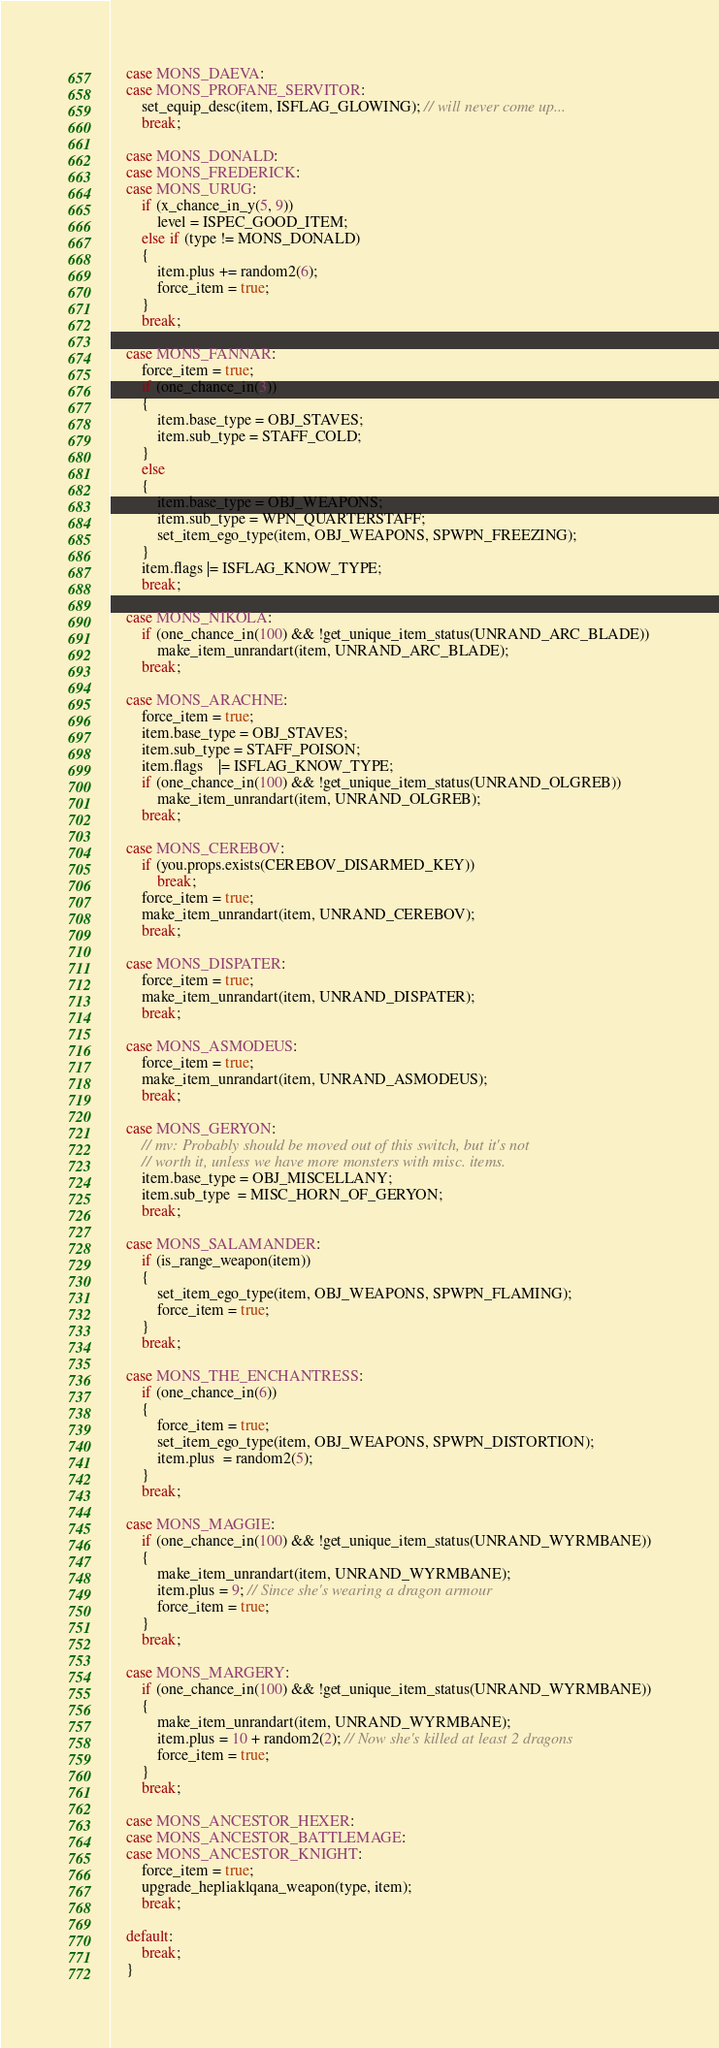<code> <loc_0><loc_0><loc_500><loc_500><_C++_>    case MONS_DAEVA:
    case MONS_PROFANE_SERVITOR:
        set_equip_desc(item, ISFLAG_GLOWING); // will never come up...
        break;

    case MONS_DONALD:
    case MONS_FREDERICK:
    case MONS_URUG:
        if (x_chance_in_y(5, 9))
            level = ISPEC_GOOD_ITEM;
        else if (type != MONS_DONALD)
        {
            item.plus += random2(6);
            force_item = true;
        }
        break;

    case MONS_FANNAR:
        force_item = true;
        if (one_chance_in(3))
        {
            item.base_type = OBJ_STAVES;
            item.sub_type = STAFF_COLD;
        }
        else
        {
            item.base_type = OBJ_WEAPONS;
            item.sub_type = WPN_QUARTERSTAFF;
            set_item_ego_type(item, OBJ_WEAPONS, SPWPN_FREEZING);
        }
        item.flags |= ISFLAG_KNOW_TYPE;
        break;

    case MONS_NIKOLA:
        if (one_chance_in(100) && !get_unique_item_status(UNRAND_ARC_BLADE))
            make_item_unrandart(item, UNRAND_ARC_BLADE);
        break;

    case MONS_ARACHNE:
        force_item = true;
        item.base_type = OBJ_STAVES;
        item.sub_type = STAFF_POISON;
        item.flags    |= ISFLAG_KNOW_TYPE;
        if (one_chance_in(100) && !get_unique_item_status(UNRAND_OLGREB))
            make_item_unrandart(item, UNRAND_OLGREB);
        break;

    case MONS_CEREBOV:
        if (you.props.exists(CEREBOV_DISARMED_KEY))
            break;
        force_item = true;
        make_item_unrandart(item, UNRAND_CEREBOV);
        break;

    case MONS_DISPATER:
        force_item = true;
        make_item_unrandart(item, UNRAND_DISPATER);
        break;

    case MONS_ASMODEUS:
        force_item = true;
        make_item_unrandart(item, UNRAND_ASMODEUS);
        break;

    case MONS_GERYON:
        // mv: Probably should be moved out of this switch, but it's not
        // worth it, unless we have more monsters with misc. items.
        item.base_type = OBJ_MISCELLANY;
        item.sub_type  = MISC_HORN_OF_GERYON;
        break;

    case MONS_SALAMANDER:
        if (is_range_weapon(item))
        {
            set_item_ego_type(item, OBJ_WEAPONS, SPWPN_FLAMING);
            force_item = true;
        }
        break;

    case MONS_THE_ENCHANTRESS:
        if (one_chance_in(6))
        {
            force_item = true;
            set_item_ego_type(item, OBJ_WEAPONS, SPWPN_DISTORTION);
            item.plus  = random2(5);
        }
        break;

    case MONS_MAGGIE:
        if (one_chance_in(100) && !get_unique_item_status(UNRAND_WYRMBANE))
        {
            make_item_unrandart(item, UNRAND_WYRMBANE);
            item.plus = 9; // Since she's wearing a dragon armour
            force_item = true;
        }
        break;

    case MONS_MARGERY:
        if (one_chance_in(100) && !get_unique_item_status(UNRAND_WYRMBANE))
        {
            make_item_unrandart(item, UNRAND_WYRMBANE);
            item.plus = 10 + random2(2); // Now she's killed at least 2 dragons
            force_item = true;
        }
        break;

    case MONS_ANCESTOR_HEXER:
    case MONS_ANCESTOR_BATTLEMAGE:
    case MONS_ANCESTOR_KNIGHT:
        force_item = true;
        upgrade_hepliaklqana_weapon(type, item);
        break;

    default:
        break;
    }
</code> 